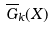<formula> <loc_0><loc_0><loc_500><loc_500>\overline { G } _ { k } ( X )</formula> 